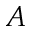Convert formula to latex. <formula><loc_0><loc_0><loc_500><loc_500>A</formula> 